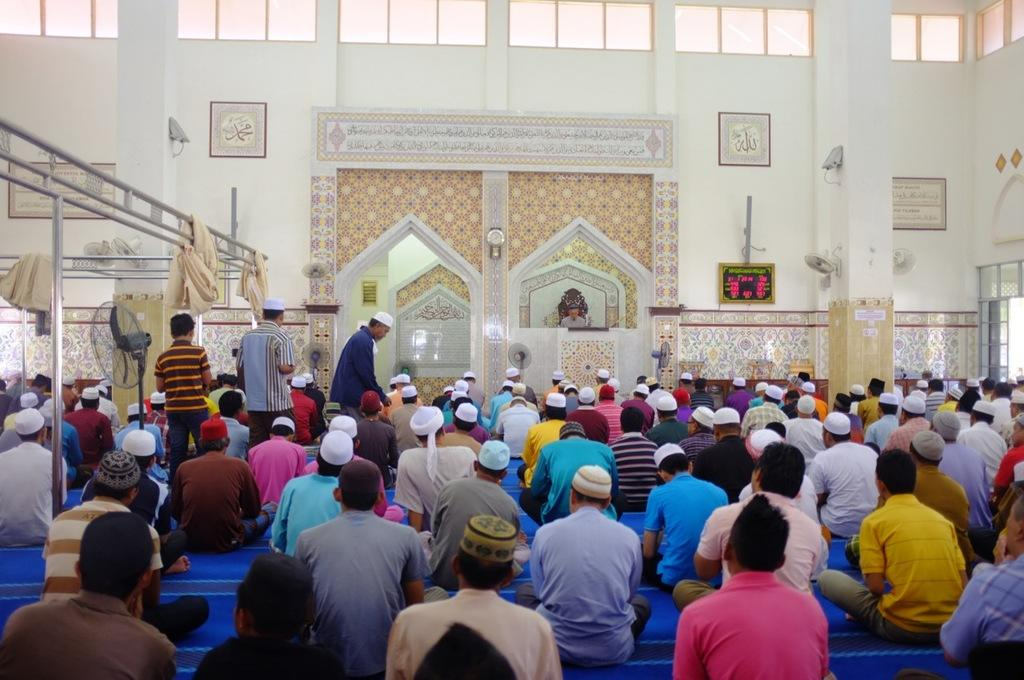What is happening in the image involving a group of people? The people in the image are sitting and doing the prayer. What are some of the people wearing in the image? Many of the people are wearing white color caps. Can you describe the setting of the image? The image appears to depict a mosque a mosque. What type of stage can be seen in the image? There is no stage present in the image. What kind of house is depicted in the image? The image does not depict a house; it appears to depict a mosque. 